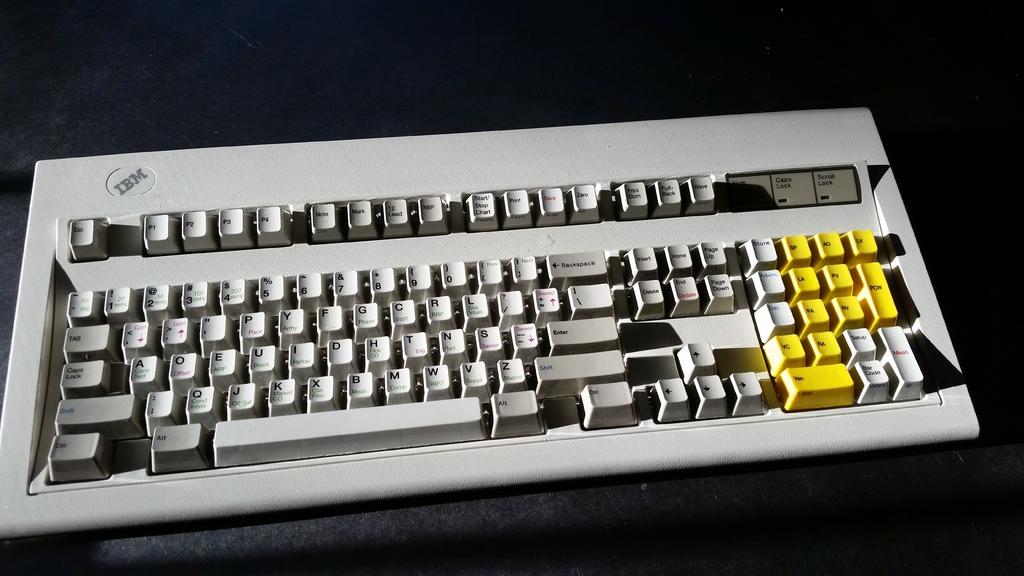Who made the keyboard?
Offer a terse response. Ibm. This is keyboard?
Keep it short and to the point. Yes. 